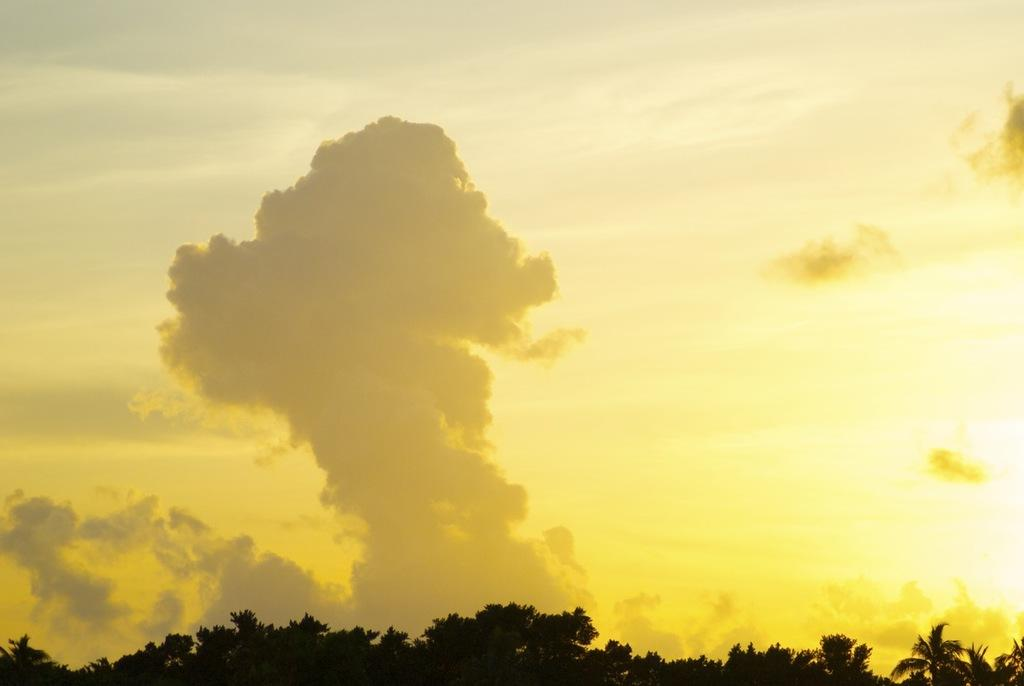What type of vegetation is present at the bottom of the image? There are trees at the bottom of the image. What part of the natural environment is visible in the image? The sky is visible in the image. How many sheep can be seen grazing in the wooded area at the bottom of the image? There are no sheep or wooded area present in the image; it features trees at the bottom and the sky visible above. Can you spot an ant crawling on the tree trunks in the image? There is no ant visible in the image; it only shows trees and the sky. 